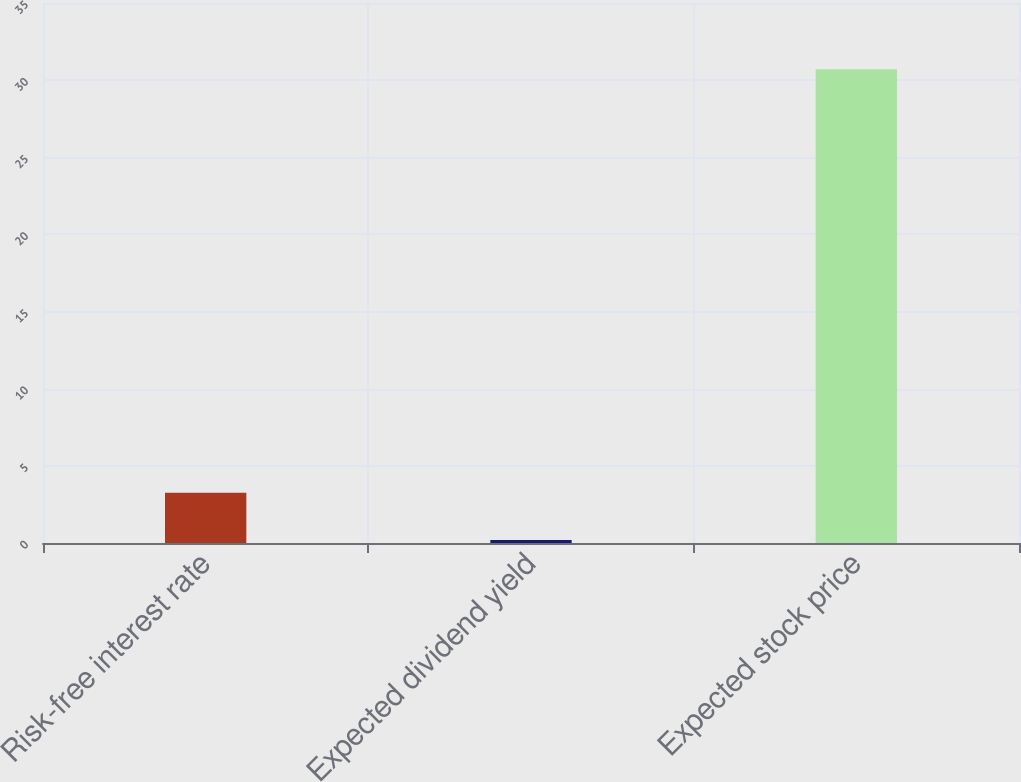Convert chart to OTSL. <chart><loc_0><loc_0><loc_500><loc_500><bar_chart><fcel>Risk-free interest rate<fcel>Expected dividend yield<fcel>Expected stock price<nl><fcel>3.25<fcel>0.2<fcel>30.7<nl></chart> 